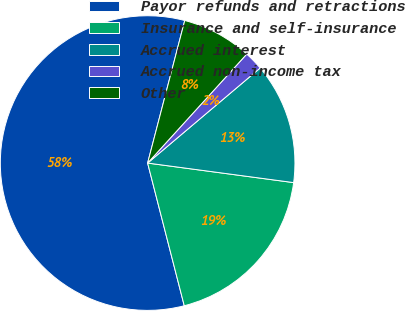Convert chart. <chart><loc_0><loc_0><loc_500><loc_500><pie_chart><fcel>Payor refunds and retractions<fcel>Insurance and self-insurance<fcel>Accrued interest<fcel>Accrued non-income tax<fcel>Other<nl><fcel>58.05%<fcel>18.88%<fcel>13.28%<fcel>2.09%<fcel>7.69%<nl></chart> 